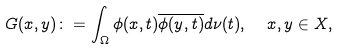Convert formula to latex. <formula><loc_0><loc_0><loc_500><loc_500>G ( x , y ) \colon = \int _ { \Omega } \phi ( x , t ) \overline { \phi ( y , t ) } d \nu ( t ) , \ \ x , y \in X ,</formula> 